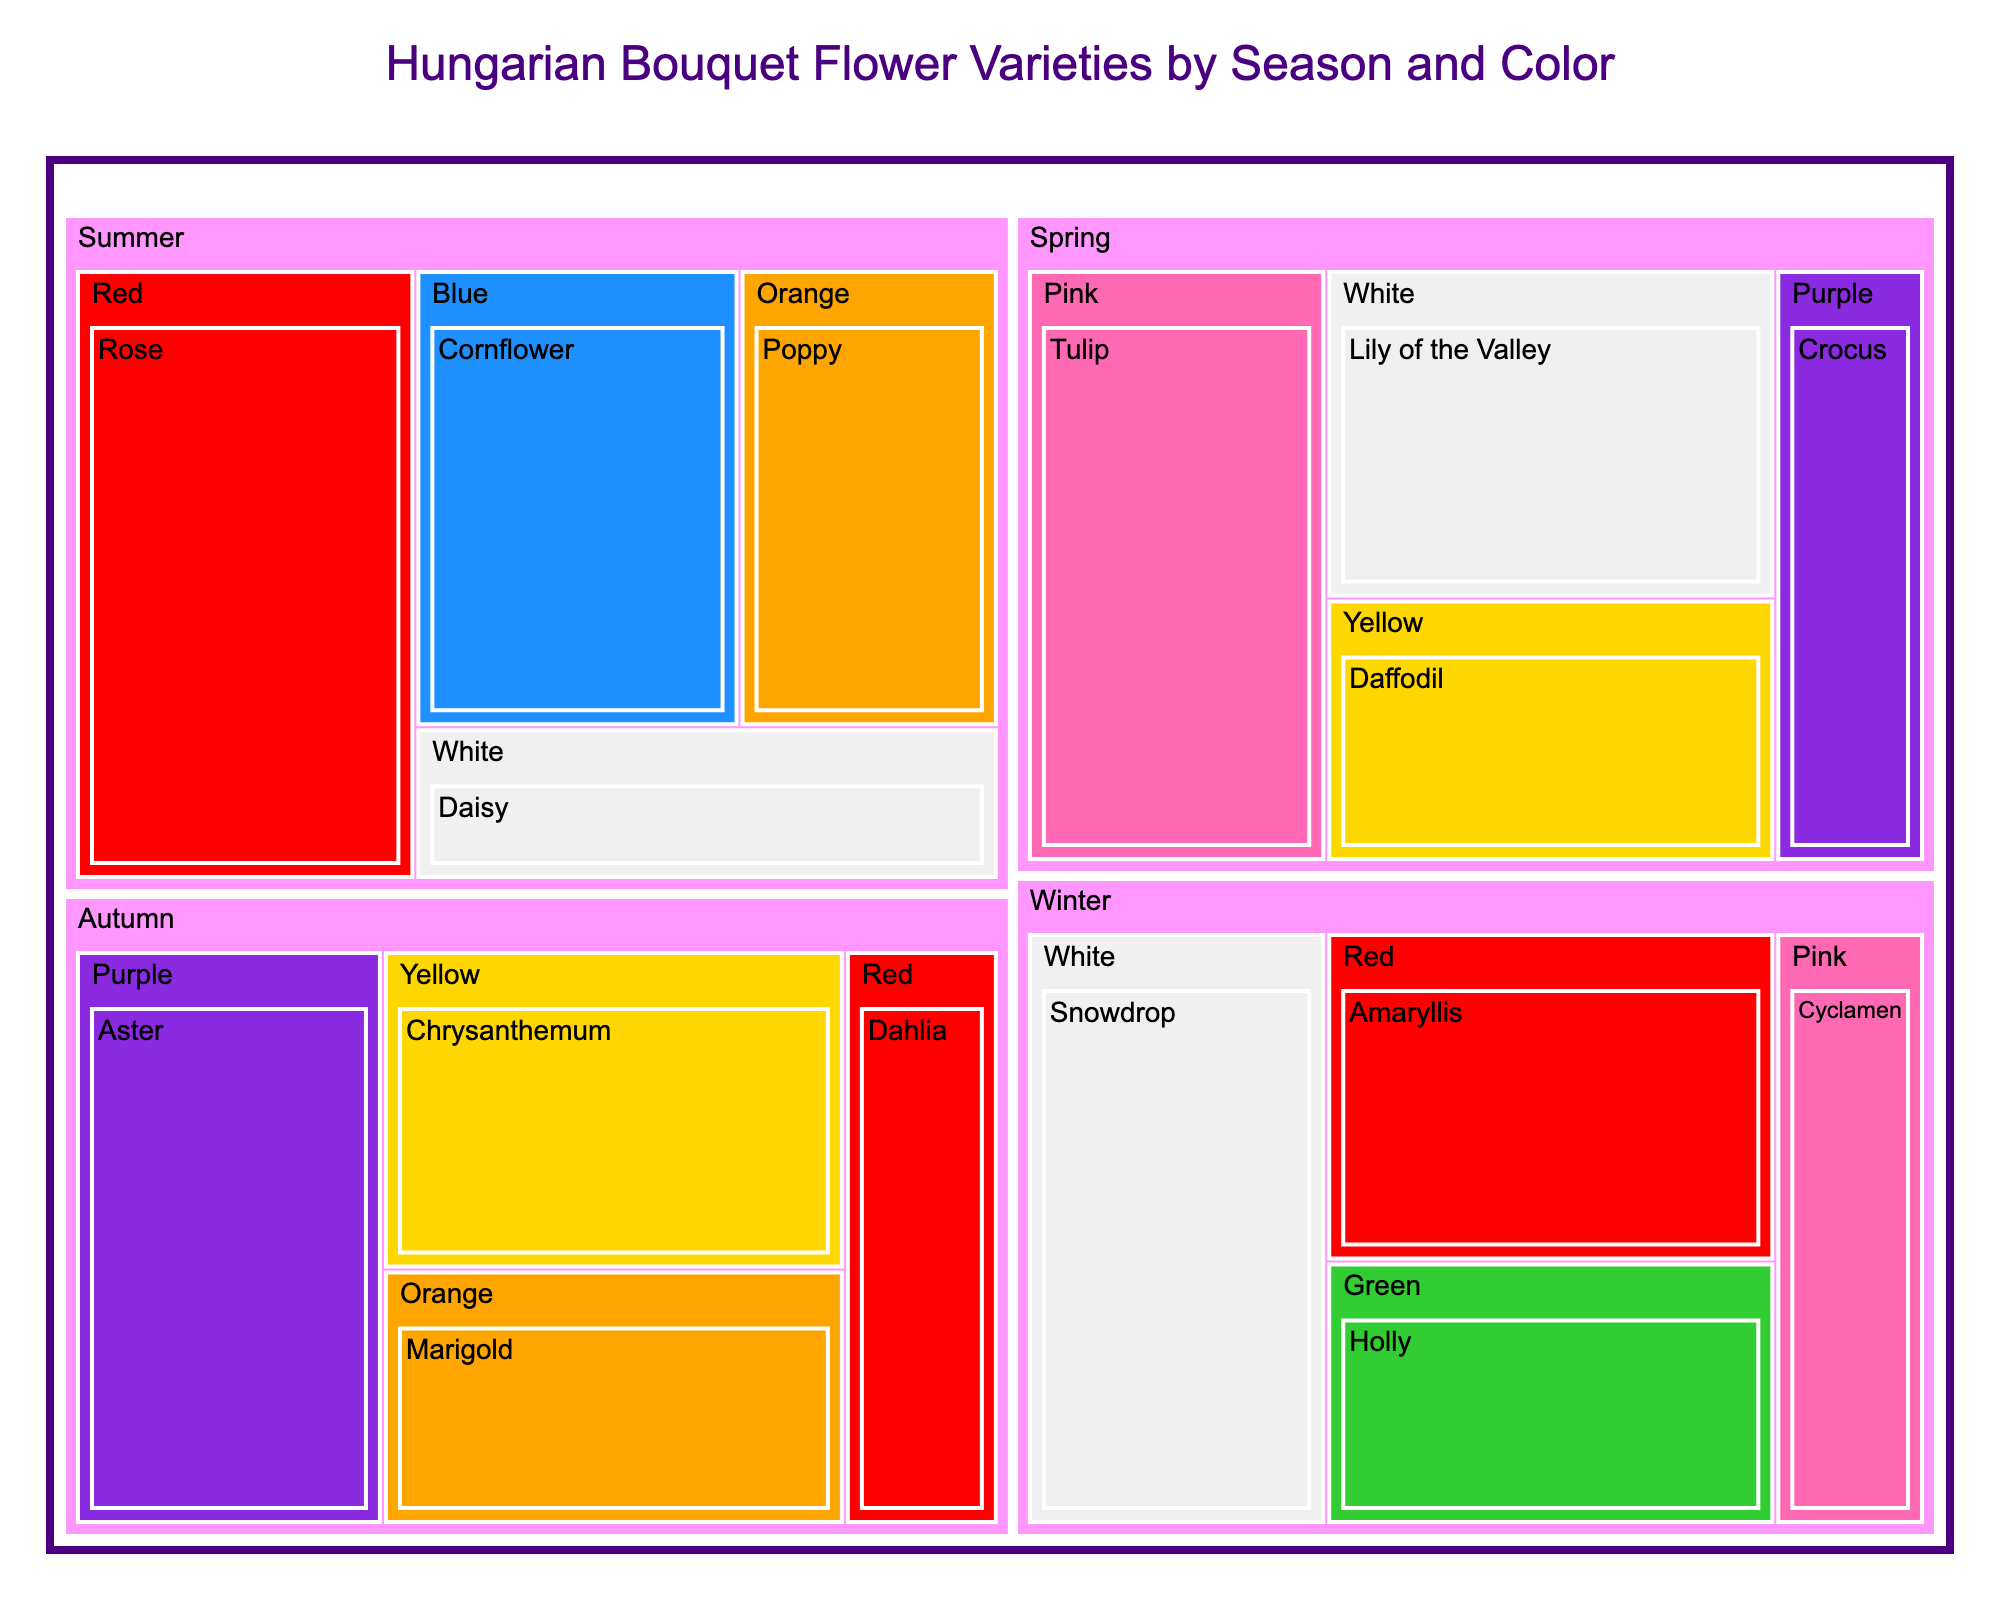How many flower types are used in bouquets for the Spring season? By looking at the treemap under the "Spring" section, we can see there are four flower types listed (Tulip, Lily of the Valley, Daffodil, and Crocus).
Answer: 4 Which season has the most variations in flower colors? Count the different colors for each season section in the treemap. Spring has Pink, White, Yellow, and Purple (4 colors); Summer has Red, Blue, Orange, and White (4 colors); Autumn has Purple, Yellow, Orange, and Red (4 colors); Winter has White, Red, Green, and Pink (4 colors). All seasons have 4 colors each.
Answer: All seasons What is the total value of flowers used in the summer bouquets? Sum the values of the flowers in the Summer section: Rose (35) + Cornflower (25) + Poppy (20) + Daisy (15) = 95.
Answer: 95 Which flower has the highest value and in which season and color is it found? Identify the highest value across all sections of the treemap. The highest value is for Red Rose in the Summer season with a value of 35.
Answer: Red Rose, Summer Is there any season where a single flower color dominates the selection of flowers used? Check each season to see if one color has significantly more flower types or higher values. The data is evenly distributed across all colors, so no single color dominates any season.
Answer: No Which color appears most frequently in winter bouquets? Count the colors in the Winter section of the treemap. Winter has one White (Snowdrop), one Red (Amaryllis), one Green (Holly), and one Pink (Cyclamen). Each color appears only once.
Answer: All colors are equally frequent How much more valuable are spring bouquets compared to autumn bouquets? Calculate the total value for Spring and Autumn, then find the difference. Spring: 30 (Tulip) + 25 (Lily of the Valley) + 20 (Daffodil) + 15 (Crocus) = 90. Autumn: 30 (Aster) + 25 (Chrysanthemum) + 20 (Marigold) + 15 (Dahlia) = 90. The difference is 90 - 90 = 0.
Answer: 0 Which flower has the lowest value and what color and season is it associated with? Identify the flower with the lowest value across the treemap segments. The lowest value is 15, associated with Crocus (Spring, Purple), Daisy (Summer, White), Dahlia (Autumn, Red), and Cyclamen (Winter, Pink).
Answer: Crocus, Daisy, Dahlia, Cyclamen (all have same value) In which season do we find the most flowers with a value of 20? Look for flowers with a value of 20 across the seasons. Spring has Daffodil (20), Summer has Poppy (20), and Autumn has Marigold (20). Winter has Holly (20). All seasons have one flower with a value of 20 each.
Answer: All seasons What is the percentage of the total value contributed by flowers in the Winter season? Calculate the proportion of Winter flowers in the total value. Total value for all seasons: 90 (Spring) + 95 (Summer) + 90 (Autumn) + 90 (Winter) = 365. Winter value = 90. The percentage is (90/365) * 100 ≈ 24.66%.
Answer: 24.66% 